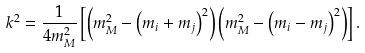<formula> <loc_0><loc_0><loc_500><loc_500>k ^ { 2 } = \frac { 1 } { 4 m ^ { 2 } _ { M } } \left [ \left ( m ^ { 2 } _ { M } - \left ( m _ { i } + m _ { j } \right ) ^ { 2 } \right ) \left ( m ^ { 2 } _ { M } - \left ( m _ { i } - m _ { j } \right ) ^ { 2 } \right ) \right ] .</formula> 